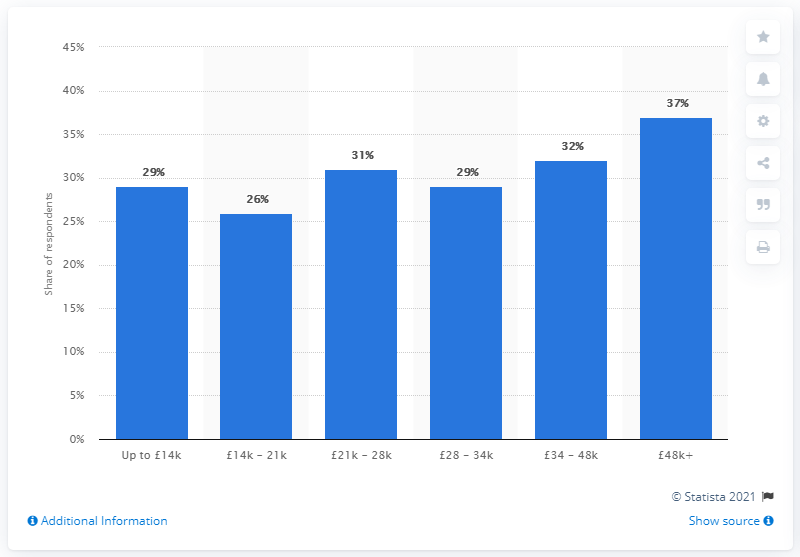Highlight a few significant elements in this photo. In 2018, 29% of all online adults in the UK used Snapchat, a social media platform known for its ephemeral messaging and multimedia features. 